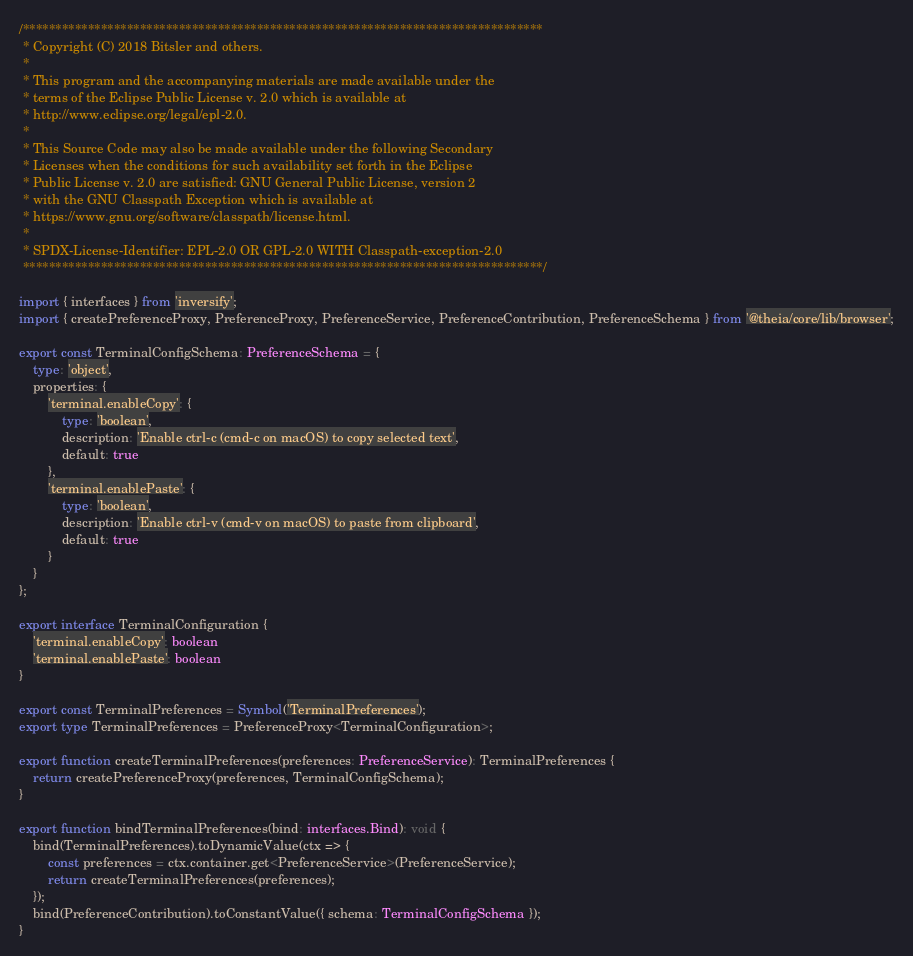<code> <loc_0><loc_0><loc_500><loc_500><_TypeScript_>/********************************************************************************
 * Copyright (C) 2018 Bitsler and others.
 *
 * This program and the accompanying materials are made available under the
 * terms of the Eclipse Public License v. 2.0 which is available at
 * http://www.eclipse.org/legal/epl-2.0.
 *
 * This Source Code may also be made available under the following Secondary
 * Licenses when the conditions for such availability set forth in the Eclipse
 * Public License v. 2.0 are satisfied: GNU General Public License, version 2
 * with the GNU Classpath Exception which is available at
 * https://www.gnu.org/software/classpath/license.html.
 *
 * SPDX-License-Identifier: EPL-2.0 OR GPL-2.0 WITH Classpath-exception-2.0
 ********************************************************************************/

import { interfaces } from 'inversify';
import { createPreferenceProxy, PreferenceProxy, PreferenceService, PreferenceContribution, PreferenceSchema } from '@theia/core/lib/browser';

export const TerminalConfigSchema: PreferenceSchema = {
    type: 'object',
    properties: {
        'terminal.enableCopy': {
            type: 'boolean',
            description: 'Enable ctrl-c (cmd-c on macOS) to copy selected text',
            default: true
        },
        'terminal.enablePaste': {
            type: 'boolean',
            description: 'Enable ctrl-v (cmd-v on macOS) to paste from clipboard',
            default: true
        }
    }
};

export interface TerminalConfiguration {
    'terminal.enableCopy': boolean
    'terminal.enablePaste': boolean
}

export const TerminalPreferences = Symbol('TerminalPreferences');
export type TerminalPreferences = PreferenceProxy<TerminalConfiguration>;

export function createTerminalPreferences(preferences: PreferenceService): TerminalPreferences {
    return createPreferenceProxy(preferences, TerminalConfigSchema);
}

export function bindTerminalPreferences(bind: interfaces.Bind): void {
    bind(TerminalPreferences).toDynamicValue(ctx => {
        const preferences = ctx.container.get<PreferenceService>(PreferenceService);
        return createTerminalPreferences(preferences);
    });
    bind(PreferenceContribution).toConstantValue({ schema: TerminalConfigSchema });
}
</code> 